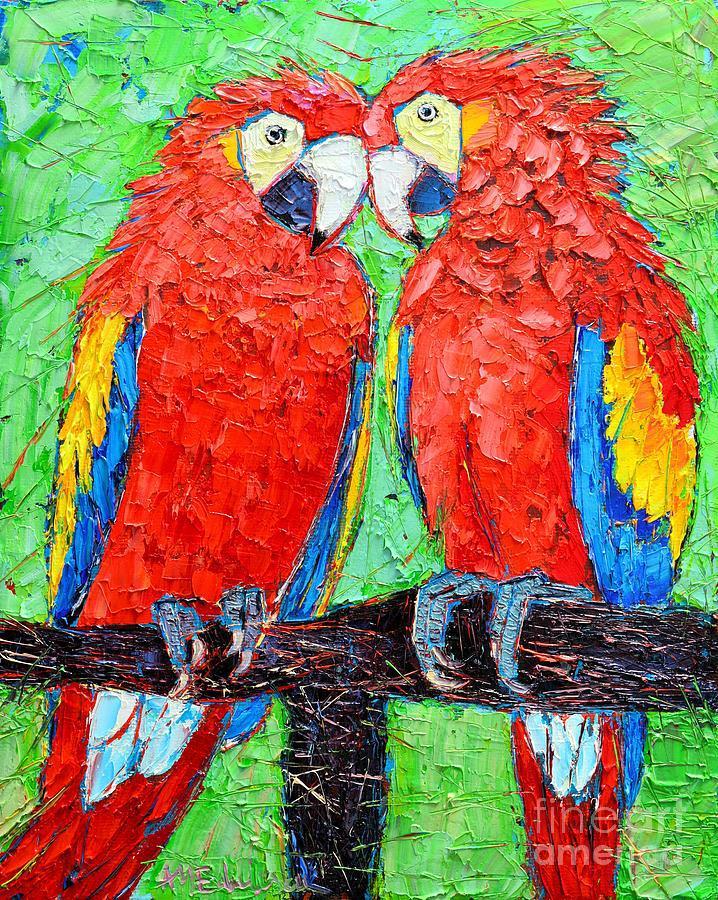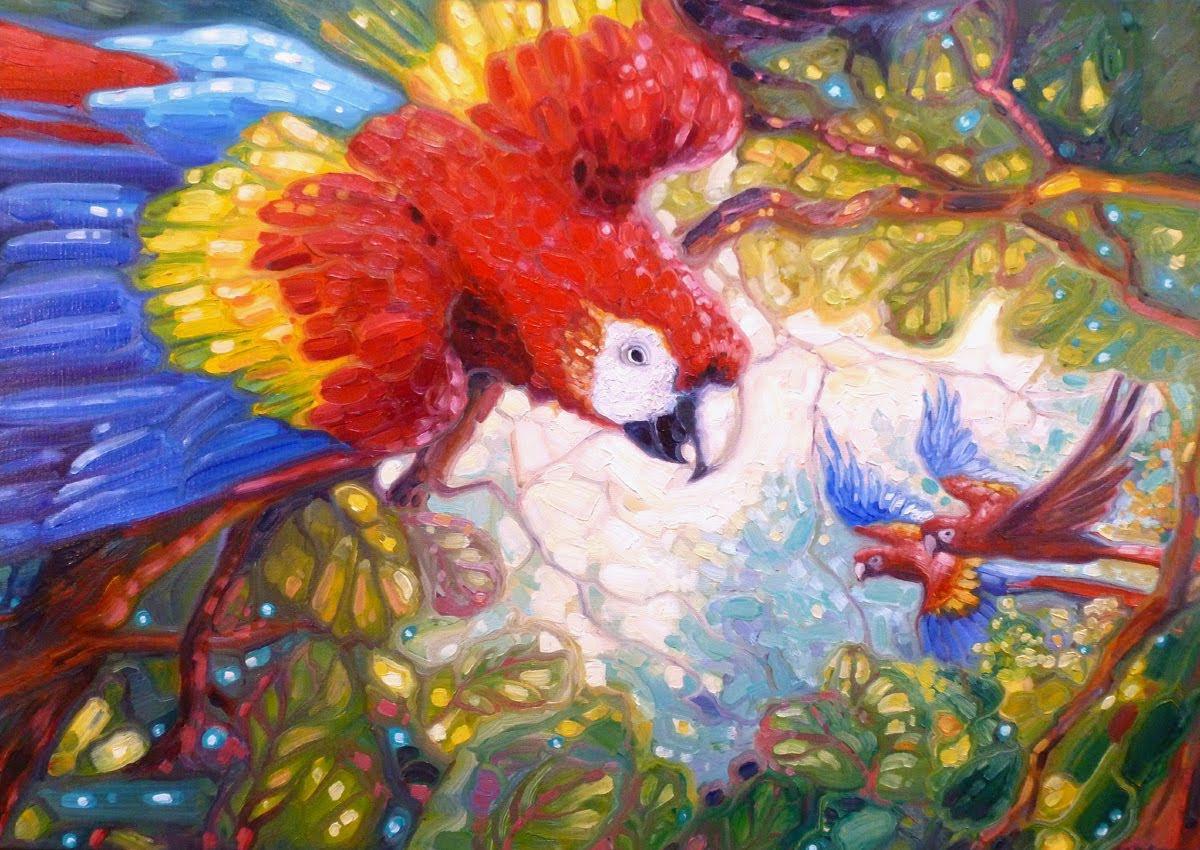The first image is the image on the left, the second image is the image on the right. Examine the images to the left and right. Is the description "Two birds are perched on the branch of a tree." accurate? Answer yes or no. No. 